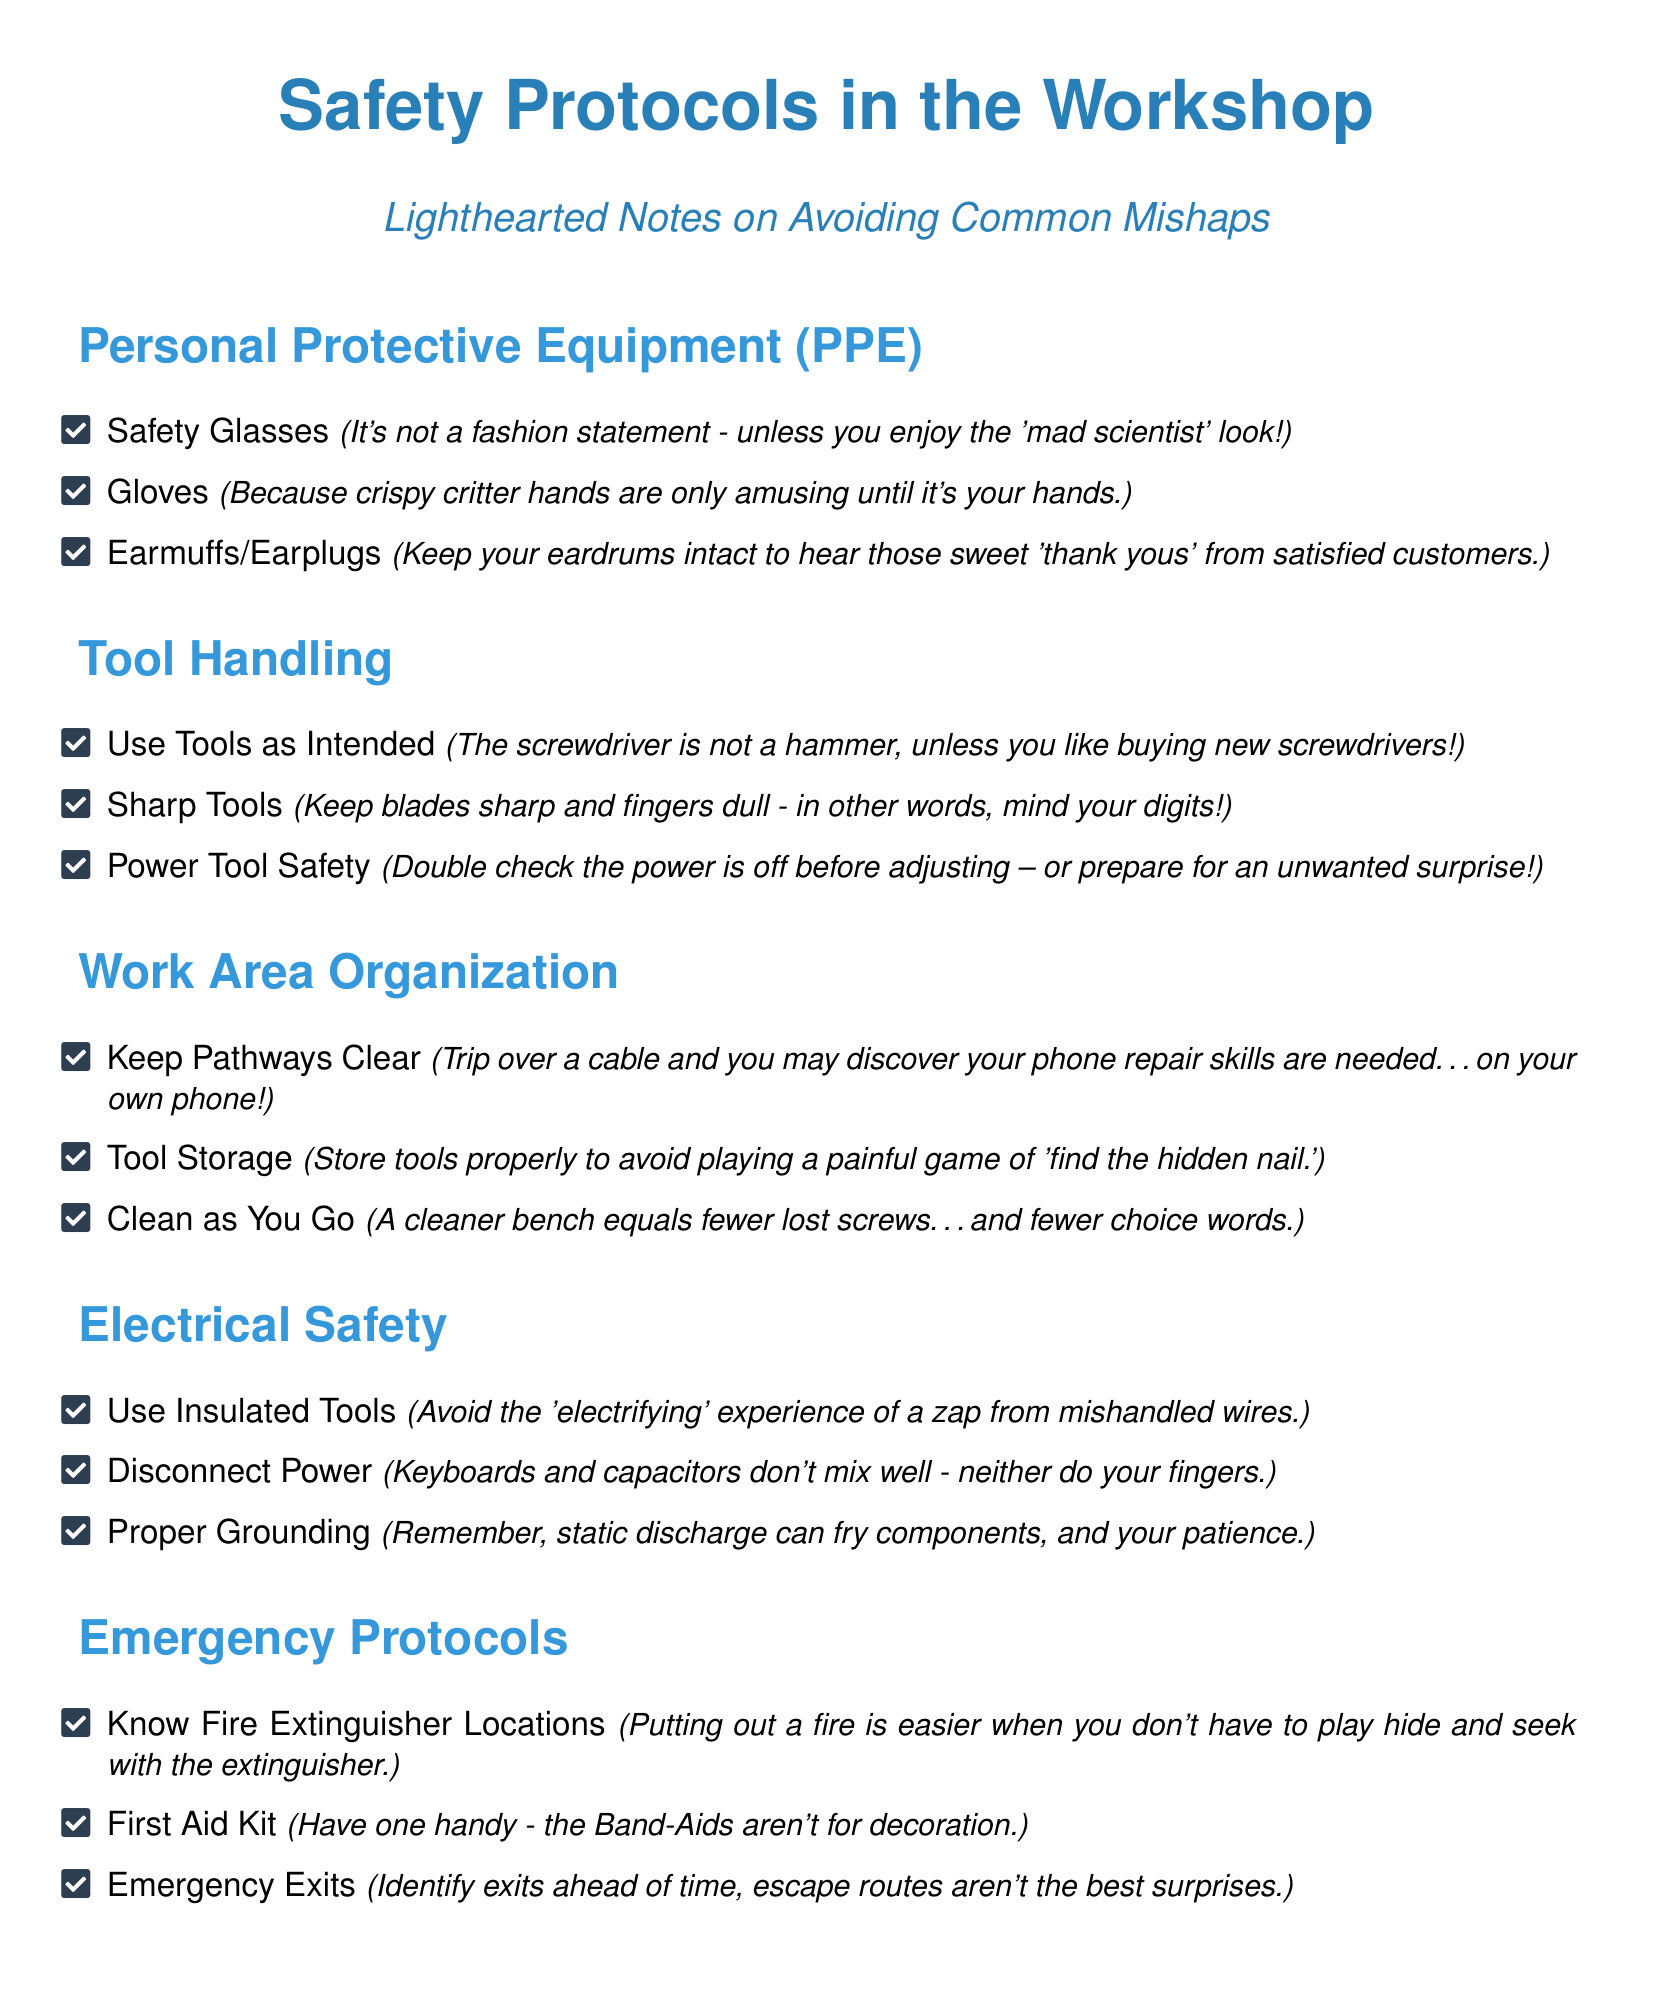What is the first item listed under Personal Protective Equipment? The first item listed under Personal Protective Equipment is Safety Glasses.
Answer: Safety Glasses How many items are in the Tool Handling section? There are three items listed in the Tool Handling section.
Answer: 3 What should you use to keep your ears safe? The document suggests Earmuffs or Earplugs to keep your ears safe.
Answer: Earmuffs/Earplugs What is mentioned about fire extinguisher locations? The document states that knowing fire extinguisher locations makes putting out a fire easier.
Answer: Fire Extinguisher Locations What humorous suggestion is made about using tools as intended? The document humorously suggests that using a screwdriver as a hammer may lead to buying new screwdrivers.
Answer: Buying new screwdrivers How many key safety areas are outlined in the checklist? The document outlines five key safety areas in the checklist.
Answer: 5 What should be kept clear to prevent tripping? Pathways should be kept clear to prevent tripping.
Answer: Pathways Clear What is the purpose of the First Aid Kit? The purpose of the First Aid Kit is to have supplies handy, as Band-Aids aren't for decoration.
Answer: Band-Aids aren't for decoration What item emphasizes minding your digits? The checklist mentions Sharp Tools, emphasizing the importance of minding your digits.
Answer: Sharp Tools 